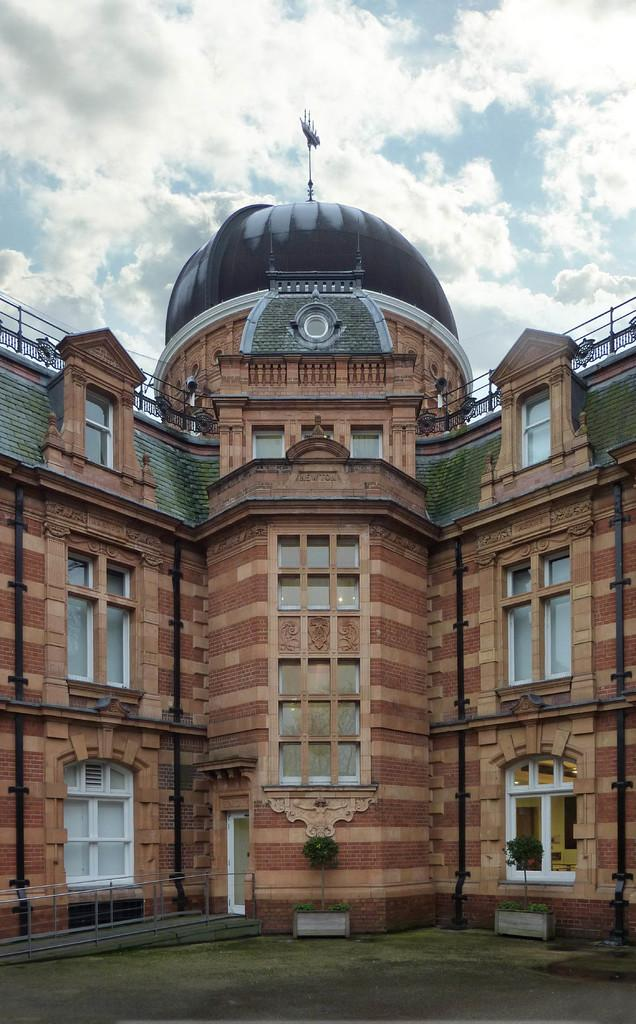What is the weather like in the image? The sky is cloudy in the image. What type of structure is visible in the image? There is a building with windows in the image. What can be seen in front of the building? There are plants in front of the building. What type of lunch is being served at the meeting in the image? There is no meeting or lunch present in the image; it only features a cloudy sky, a building with windows, and plants in front of the building. 